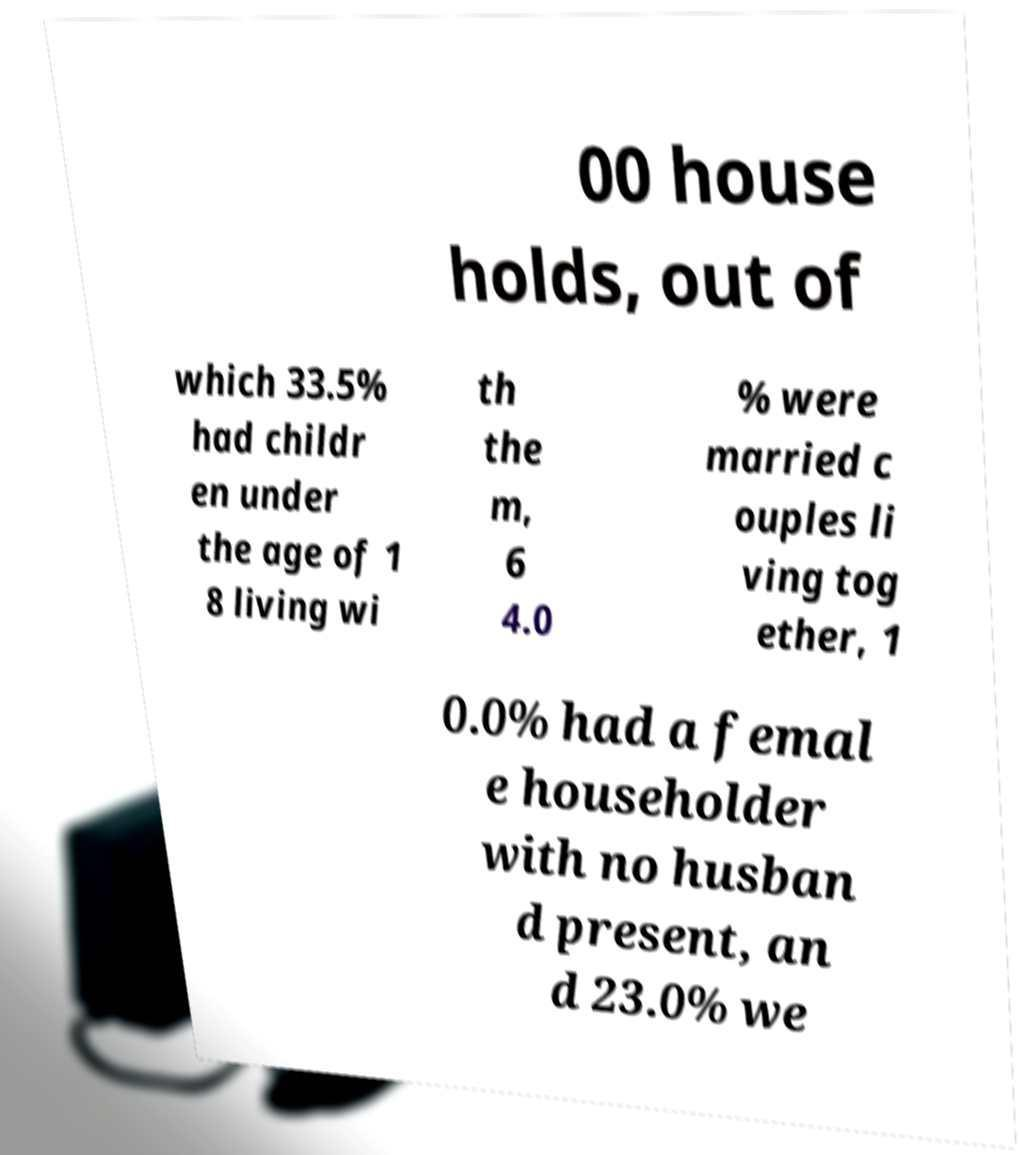Please identify and transcribe the text found in this image. 00 house holds, out of which 33.5% had childr en under the age of 1 8 living wi th the m, 6 4.0 % were married c ouples li ving tog ether, 1 0.0% had a femal e householder with no husban d present, an d 23.0% we 